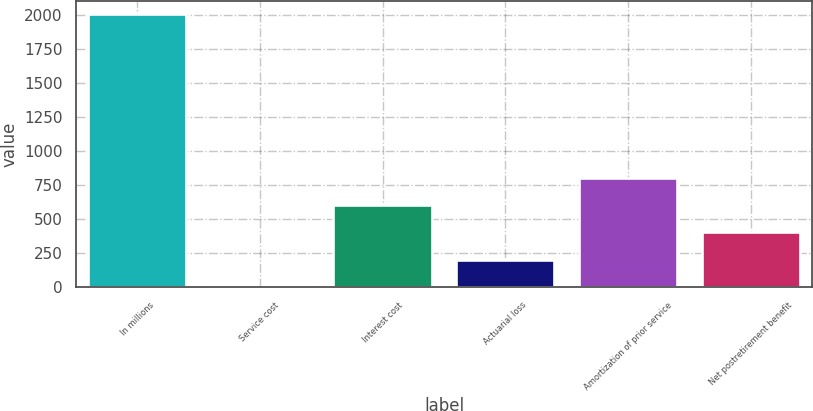Convert chart. <chart><loc_0><loc_0><loc_500><loc_500><bar_chart><fcel>In millions<fcel>Service cost<fcel>Interest cost<fcel>Actuarial loss<fcel>Amortization of prior service<fcel>Net postretirement benefit<nl><fcel>2005<fcel>2<fcel>602.9<fcel>202.3<fcel>803.2<fcel>402.6<nl></chart> 